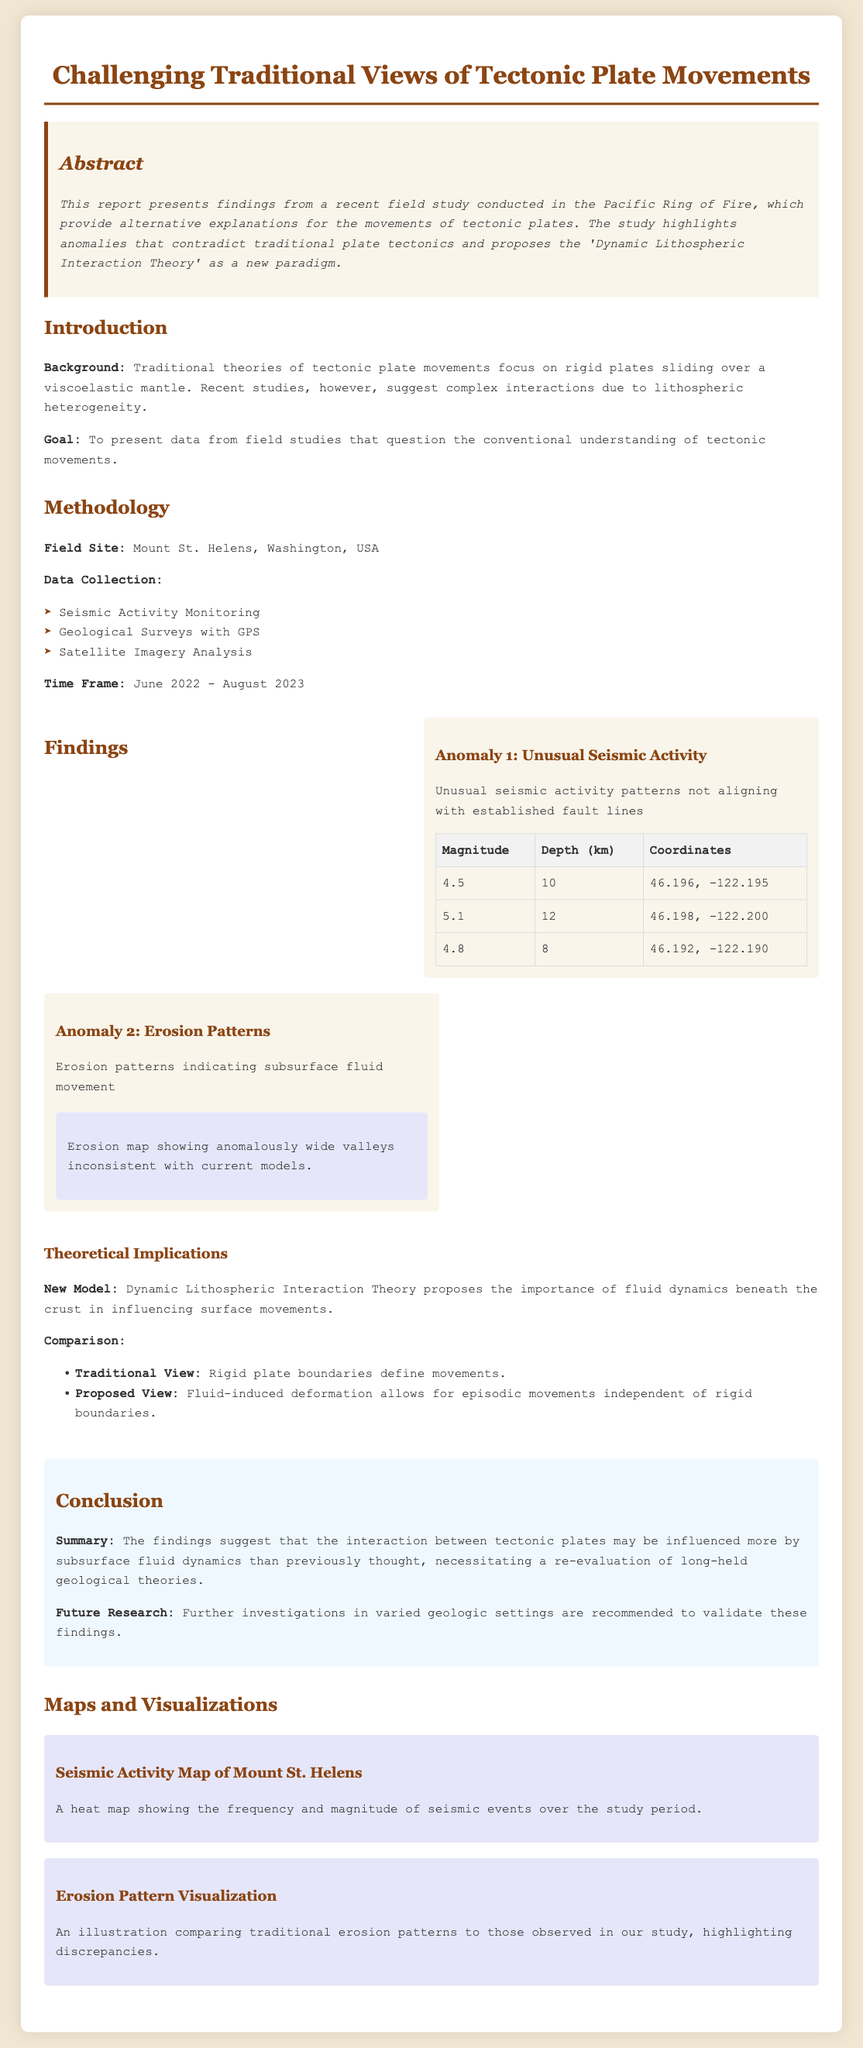What is the title of the report? The title of the report is found at the top of the document and states the main focus of the study.
Answer: Challenging Traditional Views of Tectonic Plate Movements What is the field site mentioned in the study? The field site is specified under the methodology section, indicating where the data was collected.
Answer: Mount St. Helens, Washington, USA What is the new theory proposed in the report? The new theory is highlighted in the findings section, which challenges traditional views.
Answer: Dynamic Lithospheric Interaction Theory What are the time frame dates for data collection? The time frame details when the field study was conducted and is indicated in the methodology section.
Answer: June 2022 - August 2023 What magnitude was recorded at the coordinates 46.198, -122.200? The magnitude at that specific coordinate is available in the findings section of the report.
Answer: 5.1 What does the erosion map show? The erosion map visualizes aspects related to the findings and is described in the maps and visualizations section.
Answer: Anomalously wide valleys inconsistent with current models What patterns are discussed in the findings? The findings mention specific types of anomalies observed during the study.
Answer: Unusual seismic activity and erosion patterns What does the conclusion suggest about tectonic movements? The conclusion summarizes the implications of the findings regarding existing theories.
Answer: Influenced more by subsurface fluid dynamics What type of analysis was NOT used for data collection? The methodology section lists types of analyses that were used, implying what was not included.
Answer: None 